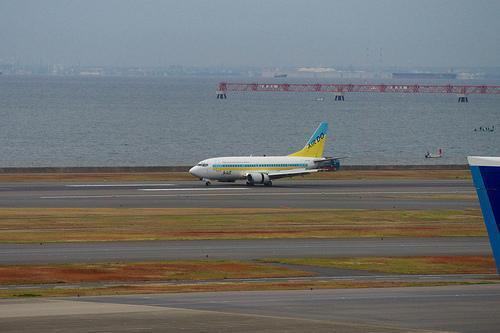How many planes are there?
Give a very brief answer. 1. 